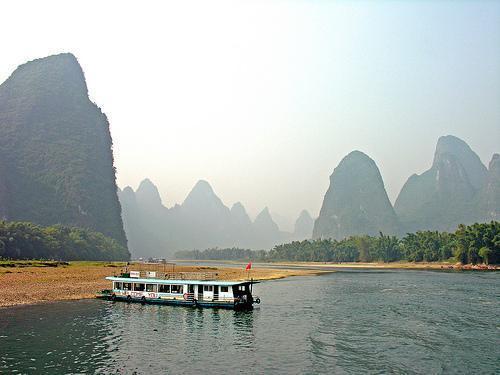How many boats are seen?
Give a very brief answer. 1. 